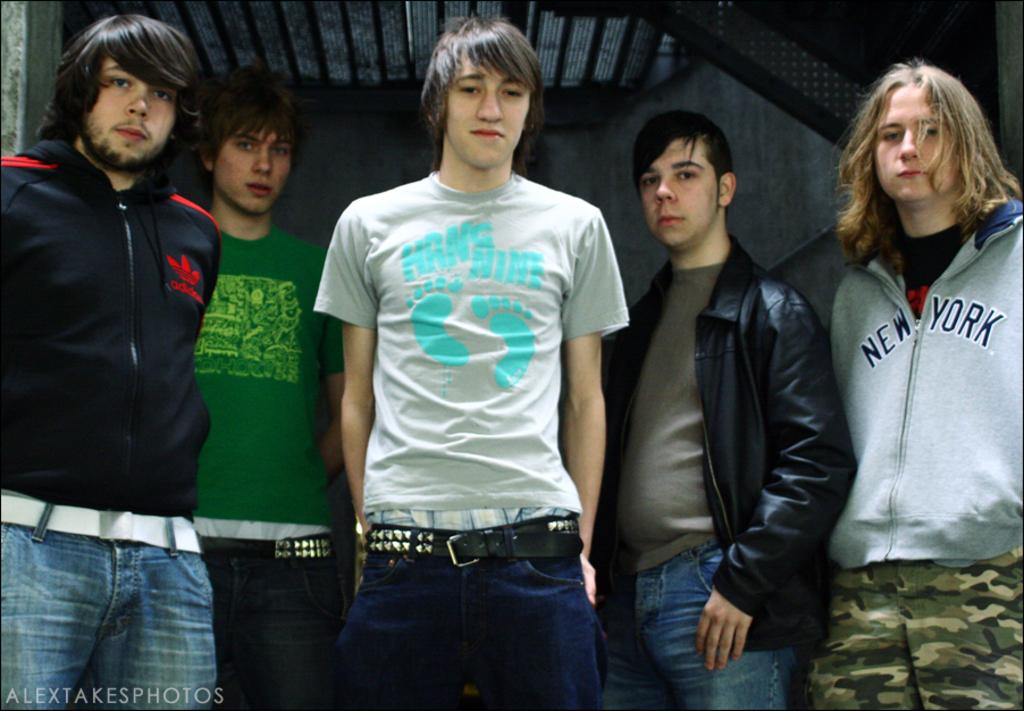How many people are in the image? There are persons standing in the image. What can be seen in the background of the image? There is a wall in the background of the image. Can you describe the clothing of one of the persons in the image? A person on the left side of the image is wearing a jacket. How many apples are on the ground in the image? There are no apples present in the image. What type of yard is visible in the image? There is no yard visible in the image. 